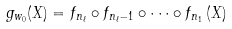<formula> <loc_0><loc_0><loc_500><loc_500>g _ { w _ { 0 } } ( X ) = f _ { n _ { \ell } } \circ f _ { n _ { \ell } - 1 } \circ \cdots \circ f _ { n _ { 1 } } \left ( X \right )</formula> 